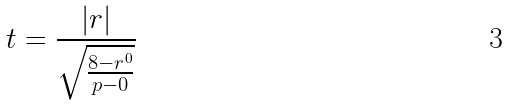<formula> <loc_0><loc_0><loc_500><loc_500>t = \frac { | r | } { \sqrt { \frac { 8 - r ^ { 0 } } { p - 0 } } }</formula> 